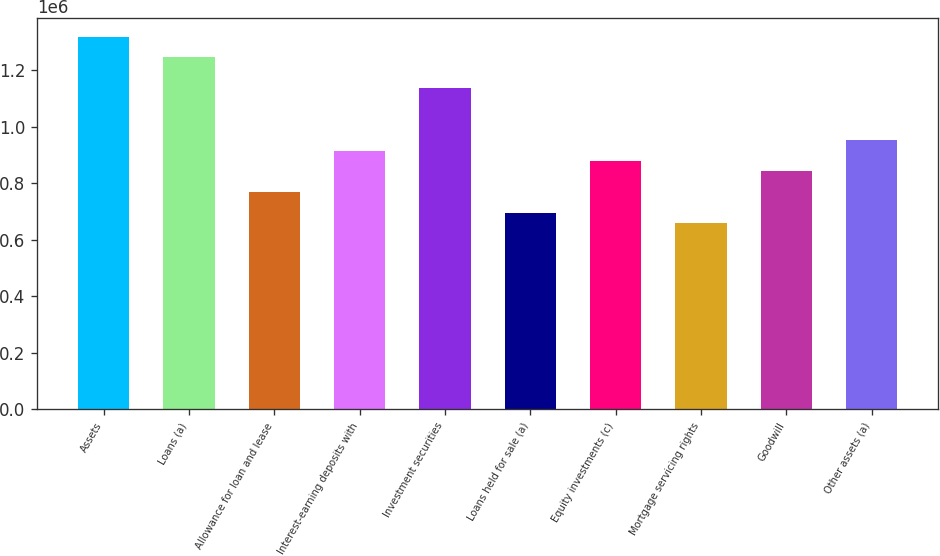<chart> <loc_0><loc_0><loc_500><loc_500><bar_chart><fcel>Assets<fcel>Loans (a)<fcel>Allowance for loan and lease<fcel>Interest-earning deposits with<fcel>Investment securities<fcel>Loans held for sale (a)<fcel>Equity investments (c)<fcel>Mortgage servicing rights<fcel>Goodwill<fcel>Other assets (a)<nl><fcel>1.31897e+06<fcel>1.24569e+06<fcel>769397<fcel>915948<fcel>1.13578e+06<fcel>696121<fcel>879310<fcel>659483<fcel>842673<fcel>952586<nl></chart> 